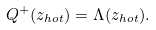Convert formula to latex. <formula><loc_0><loc_0><loc_500><loc_500>Q ^ { + } ( z _ { h o t } ) = \Lambda ( z _ { h o t } ) .</formula> 